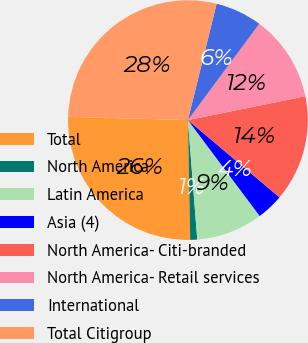Convert chart. <chart><loc_0><loc_0><loc_500><loc_500><pie_chart><fcel>Total<fcel>North America<fcel>Latin America<fcel>Asia (4)<fcel>North America- Citi-branded<fcel>North America- Retail services<fcel>International<fcel>Total Citigroup<nl><fcel>25.74%<fcel>0.94%<fcel>8.98%<fcel>3.62%<fcel>14.34%<fcel>11.66%<fcel>6.3%<fcel>28.42%<nl></chart> 